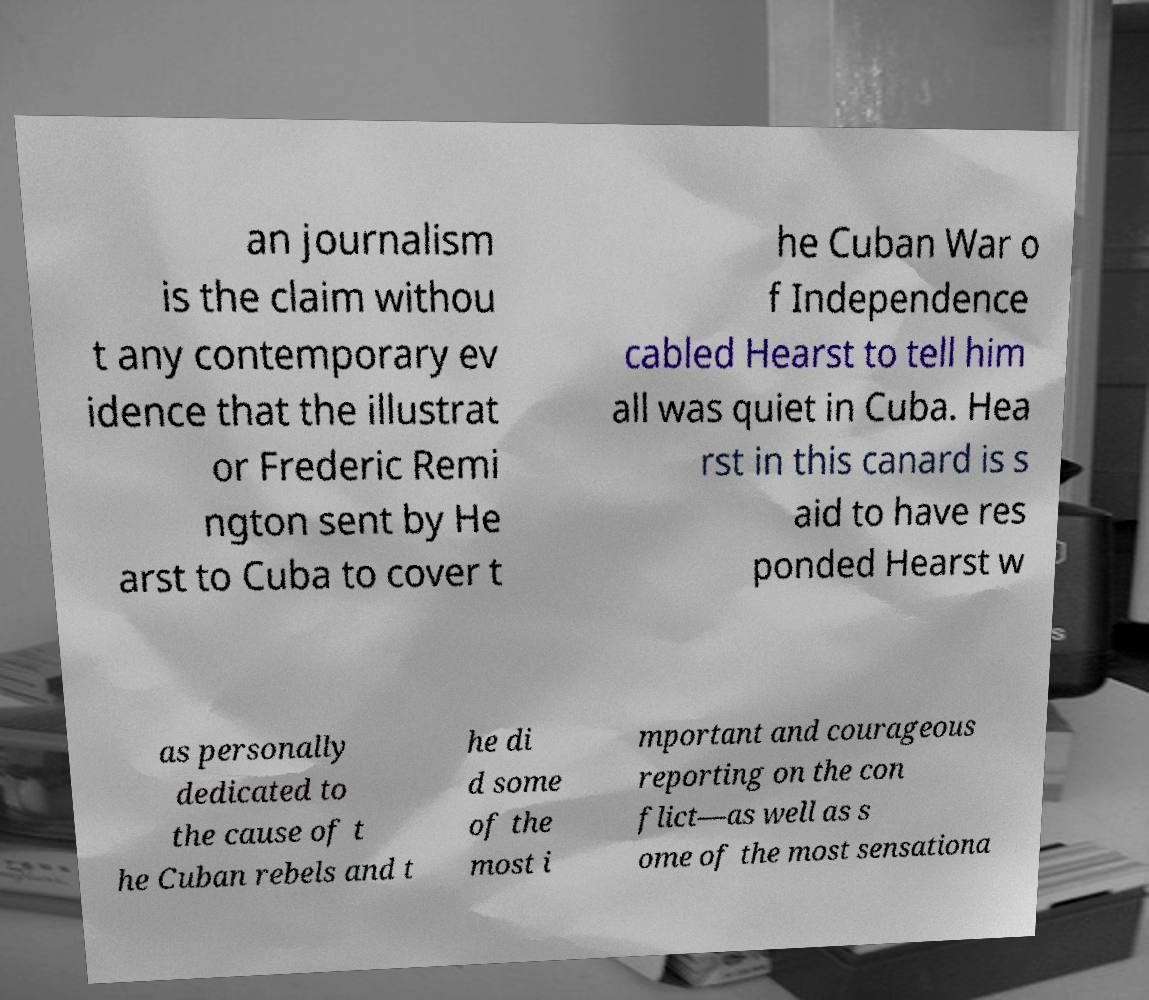Can you accurately transcribe the text from the provided image for me? an journalism is the claim withou t any contemporary ev idence that the illustrat or Frederic Remi ngton sent by He arst to Cuba to cover t he Cuban War o f Independence cabled Hearst to tell him all was quiet in Cuba. Hea rst in this canard is s aid to have res ponded Hearst w as personally dedicated to the cause of t he Cuban rebels and t he di d some of the most i mportant and courageous reporting on the con flict—as well as s ome of the most sensationa 